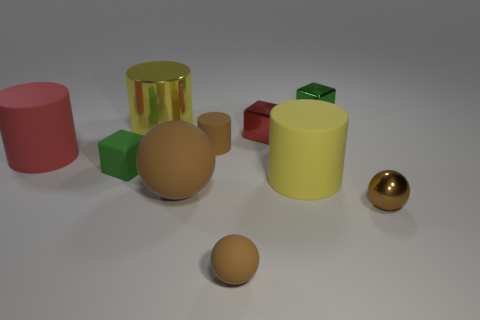Subtract all small brown matte cylinders. How many cylinders are left? 3 Subtract all blocks. How many objects are left? 7 Subtract all brown cylinders. How many green blocks are left? 2 Subtract all yellow cylinders. How many cylinders are left? 2 Subtract 2 cubes. How many cubes are left? 1 Subtract all cyan cubes. Subtract all red balls. How many cubes are left? 3 Subtract all tiny brown things. Subtract all large blue spheres. How many objects are left? 7 Add 7 brown spheres. How many brown spheres are left? 10 Add 2 small rubber balls. How many small rubber balls exist? 3 Subtract 1 brown cylinders. How many objects are left? 9 